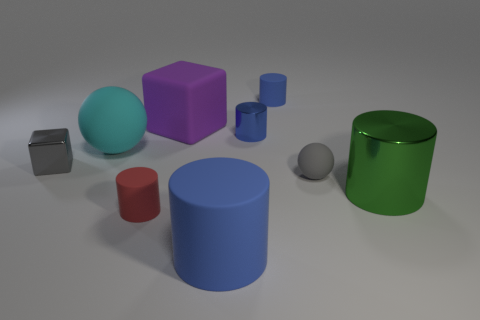Are there any other things that are made of the same material as the green cylinder?
Offer a very short reply. Yes. What number of objects are cyan matte objects or shiny cylinders in front of the cyan sphere?
Offer a very short reply. 2. What size is the rubber thing that is behind the gray sphere and in front of the small blue metallic cylinder?
Keep it short and to the point. Large. Are there more big cyan rubber objects that are right of the big blue object than tiny metallic objects that are in front of the green cylinder?
Give a very brief answer. No. Does the tiny red rubber object have the same shape as the matte thing behind the large matte cube?
Give a very brief answer. Yes. What number of other things are the same shape as the blue metal thing?
Give a very brief answer. 4. The thing that is both behind the red object and in front of the small gray ball is what color?
Your response must be concise. Green. What color is the large rubber cylinder?
Offer a very short reply. Blue. Do the green object and the small object that is in front of the tiny gray matte ball have the same material?
Your answer should be compact. No. There is a large blue object that is made of the same material as the gray sphere; what shape is it?
Your answer should be compact. Cylinder. 